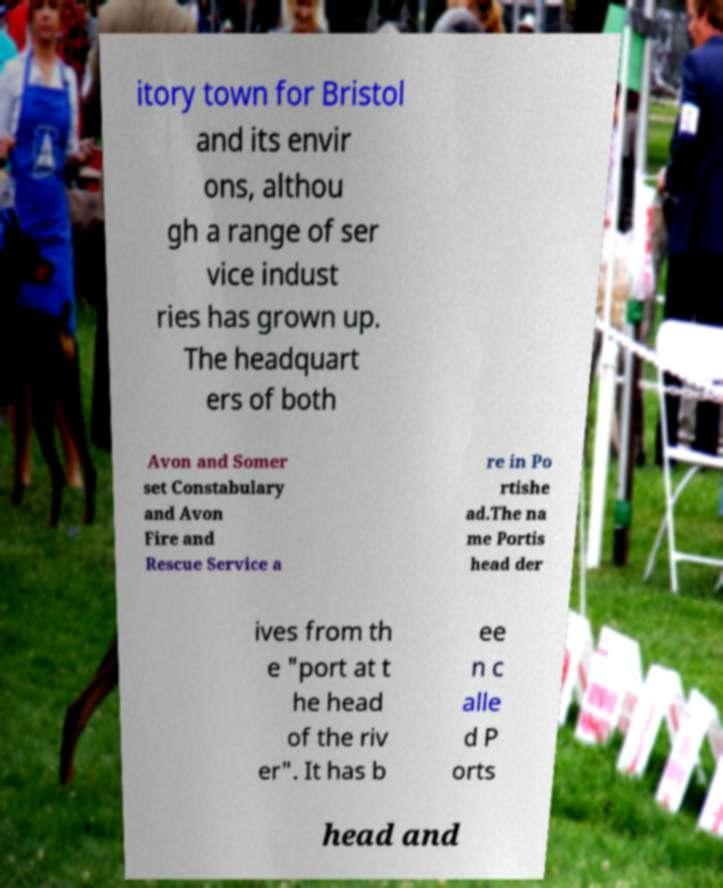Can you read and provide the text displayed in the image?This photo seems to have some interesting text. Can you extract and type it out for me? itory town for Bristol and its envir ons, althou gh a range of ser vice indust ries has grown up. The headquart ers of both Avon and Somer set Constabulary and Avon Fire and Rescue Service a re in Po rtishe ad.The na me Portis head der ives from th e "port at t he head of the riv er". It has b ee n c alle d P orts head and 